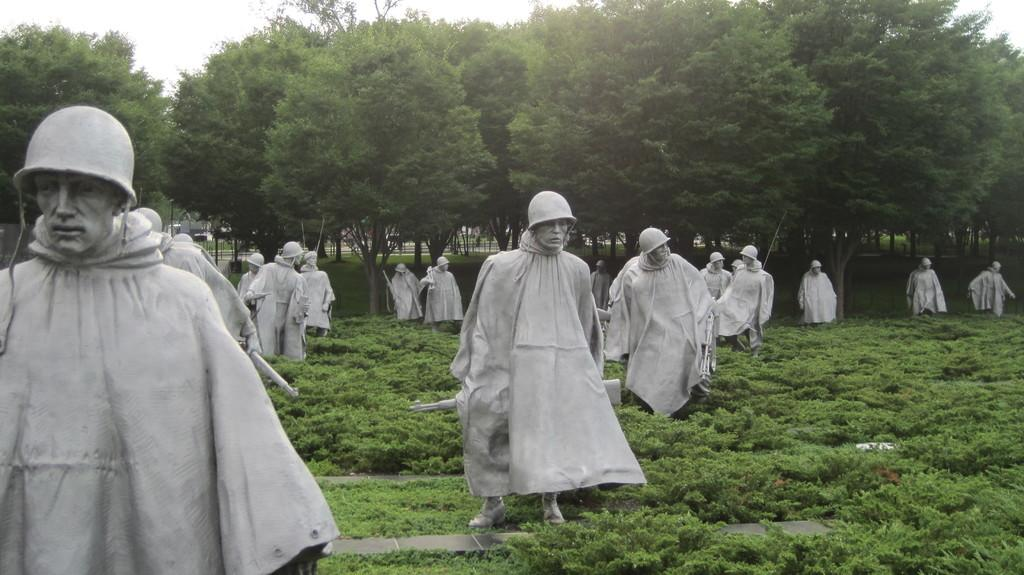What type of artwork can be seen in the image? There are sculptures in the image. What type of natural environment is present in the image? There is grass, plants, and trees in the image. What is visible at the top of the image? The sky is visible at the top of the image. What type of structure is being tested in the image? There is no structure being tested in the image; it features sculptures, grass, plants, trees, and the sky. Can you tell me how many tubs are visible in the image? There are no tubs present in the image. 